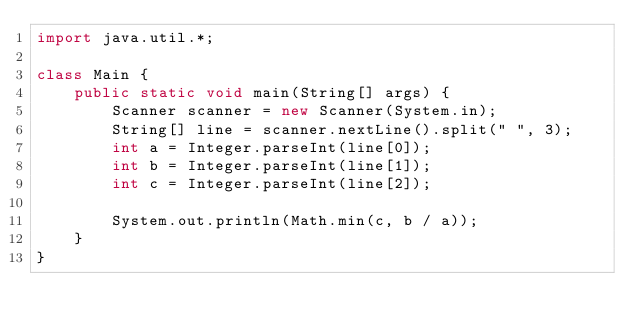<code> <loc_0><loc_0><loc_500><loc_500><_Java_>import java.util.*;

class Main {
    public static void main(String[] args) {
        Scanner scanner = new Scanner(System.in);
        String[] line = scanner.nextLine().split(" ", 3);
        int a = Integer.parseInt(line[0]);
        int b = Integer.parseInt(line[1]);
        int c = Integer.parseInt(line[2]);

        System.out.println(Math.min(c, b / a));
    }
}
</code> 